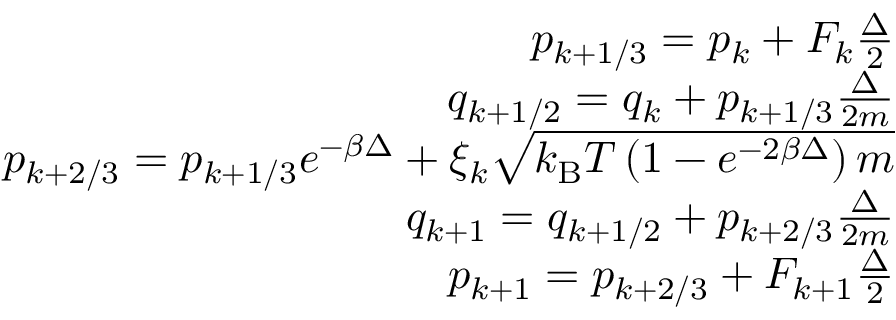<formula> <loc_0><loc_0><loc_500><loc_500>\begin{array} { r } { p _ { k + 1 / 3 } = p _ { k } + F _ { k } \frac { \Delta } { 2 } } \\ { q _ { k + 1 / 2 } = q _ { k } + p _ { k + 1 / 3 } \frac { \Delta } { 2 m } } \\ { p _ { k + 2 / 3 } = p _ { k + 1 / 3 } e ^ { - \beta \Delta } + \xi _ { k } \sqrt { k _ { B } T \left ( 1 - e ^ { - 2 \beta \Delta } \right ) m } } \\ { q _ { k + 1 } = q _ { k + 1 / 2 } + p _ { k + 2 / 3 } \frac { \Delta } { 2 m } } \\ { p _ { k + 1 } = p _ { k + 2 / 3 } + F _ { k + 1 } \frac { \Delta } { 2 } } \end{array}</formula> 